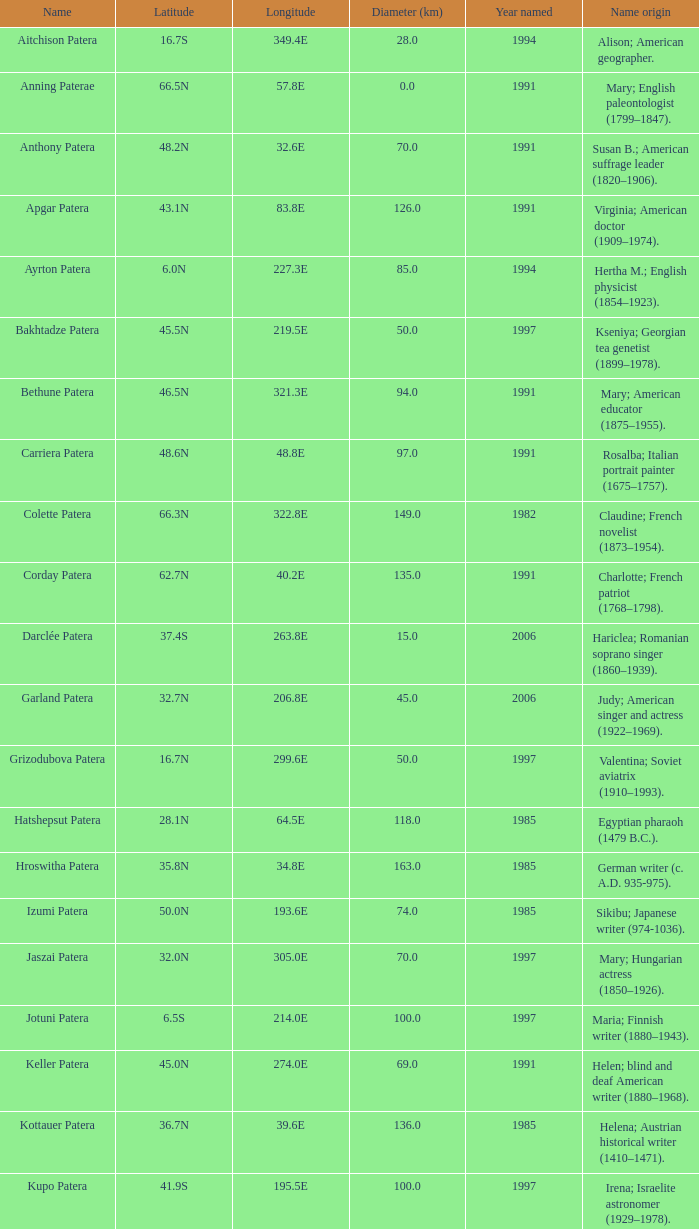What is the longitudinal coordinate of the geographical feature called razia patera? 197.8E. 